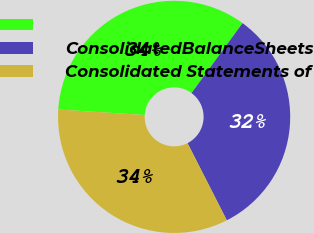Convert chart to OTSL. <chart><loc_0><loc_0><loc_500><loc_500><pie_chart><ecel><fcel>ConsolidatedBalanceSheets<fcel>Consolidated Statements of<nl><fcel>34.02%<fcel>32.47%<fcel>33.51%<nl></chart> 